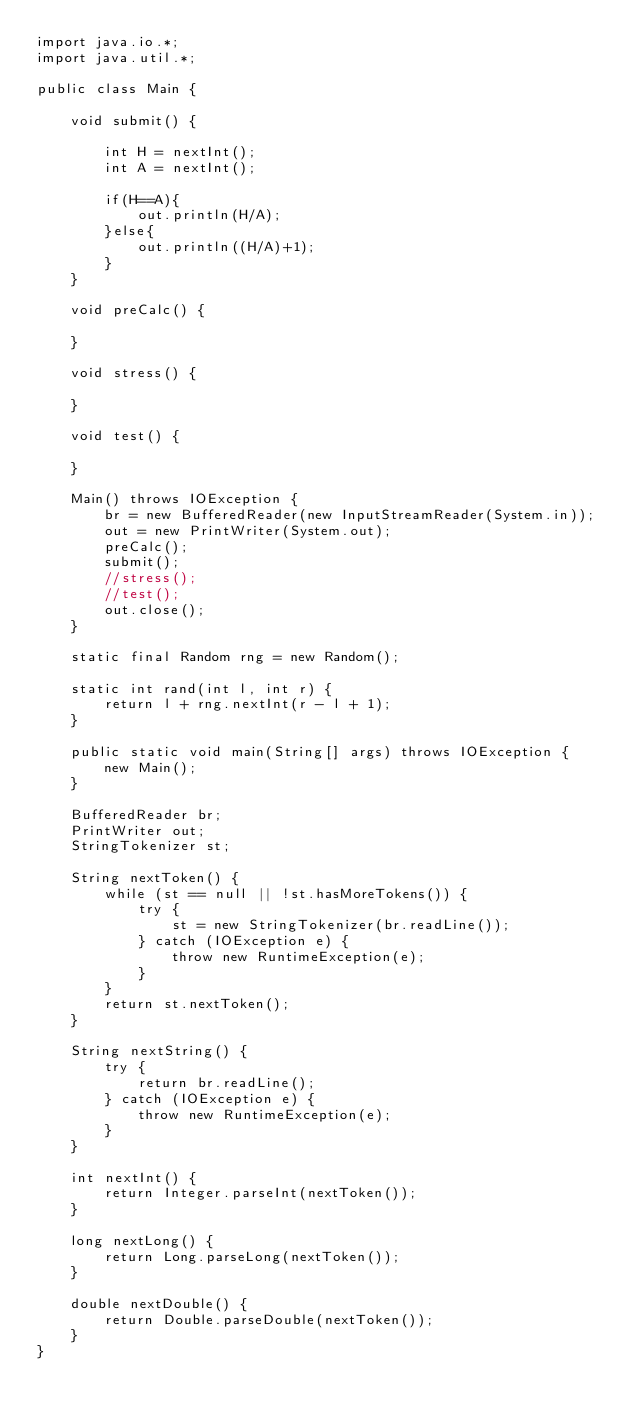<code> <loc_0><loc_0><loc_500><loc_500><_Java_>import java.io.*;
import java.util.*;
 
public class Main {
 
	void submit() {

        int H = nextInt();
        int A = nextInt();
        
        if(H==A){
    	    out.println(H/A);            
        }else{
    	    out.println((H/A)+1);
        }
	}
 
	void preCalc() {
 
	}
 
	void stress() {
 
	}
 
	void test() {
 
	}
 
	Main() throws IOException {
		br = new BufferedReader(new InputStreamReader(System.in));
		out = new PrintWriter(System.out);
		preCalc();
		submit();
		//stress();
		//test();
		out.close();
	}
 
	static final Random rng = new Random();
 
	static int rand(int l, int r) {
		return l + rng.nextInt(r - l + 1);
	}
 
	public static void main(String[] args) throws IOException {
		new Main();
	}
 
	BufferedReader br;
	PrintWriter out;
	StringTokenizer st;
 
	String nextToken() {
		while (st == null || !st.hasMoreTokens()) {
			try {
				st = new StringTokenizer(br.readLine());
			} catch (IOException e) {
				throw new RuntimeException(e);
			}
		}
		return st.nextToken();
	}
 
	String nextString() {
		try {
			return br.readLine();
		} catch (IOException e) {
			throw new RuntimeException(e);
		}
	}
 
	int nextInt() {
		return Integer.parseInt(nextToken());
	}
 
	long nextLong() {
		return Long.parseLong(nextToken());
	}
 
	double nextDouble() {
		return Double.parseDouble(nextToken());
	}
}</code> 